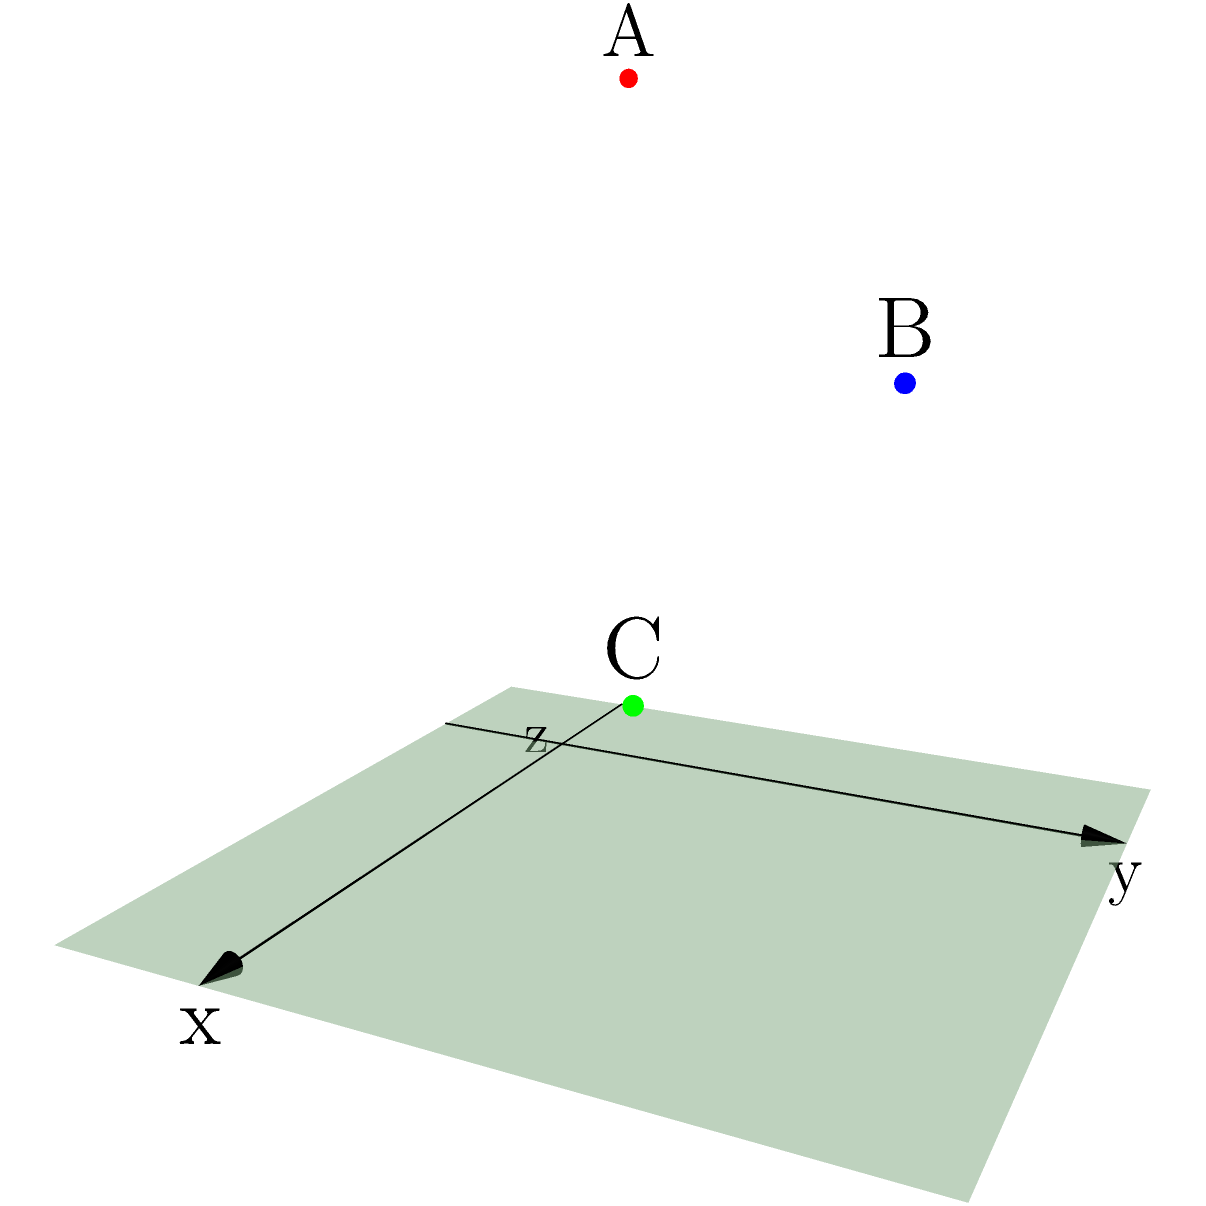In a 3D coordinate system, three child-friendly locations are plotted: a playground (A) at (1,1,3), a library (B) at (2,3,2), and a community center (C) at (3,2,1). What is the total vertical distance (along the z-axis) between the highest and lowest points? To find the total vertical distance between the highest and lowest points, we need to:

1. Identify the z-coordinates of all points:
   A: z = 3
   B: z = 2
   C: z = 1

2. Determine the highest point:
   The highest point is A with z = 3

3. Determine the lowest point:
   The lowest point is C with z = 1

4. Calculate the difference between the highest and lowest z-coordinates:
   Vertical distance = Highest z - Lowest z
   $$ \text{Vertical distance} = 3 - 1 = 2 $$

Therefore, the total vertical distance between the highest and lowest points is 2 units.
Answer: 2 units 